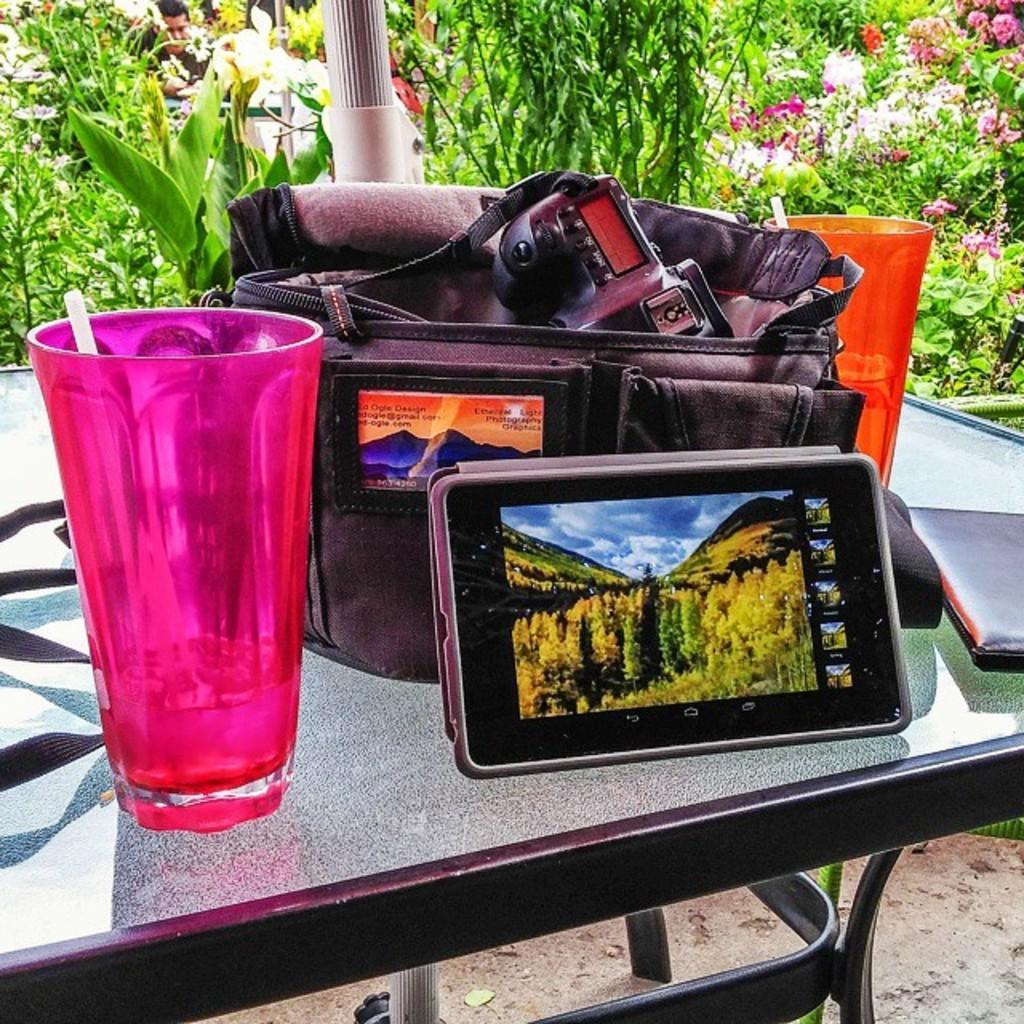Can you describe this image briefly? In this picture, we see a table on which pink glass, mobile phone, black bag, orange glass and book are placed. Behind that, we see many trees and plants. 